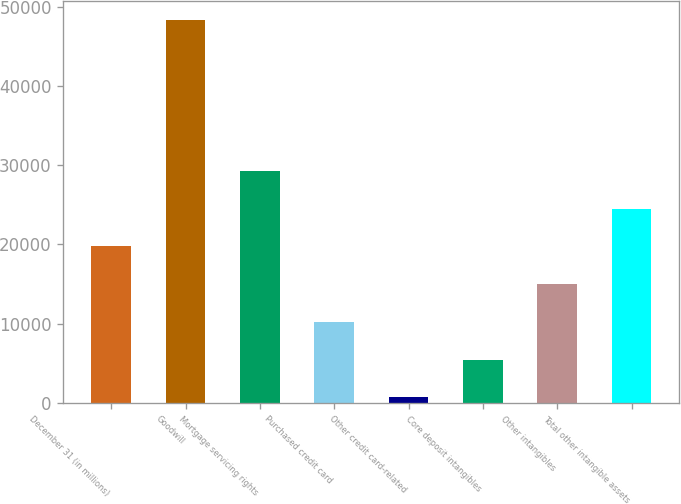Convert chart to OTSL. <chart><loc_0><loc_0><loc_500><loc_500><bar_chart><fcel>December 31 (in millions)<fcel>Goodwill<fcel>Mortgage servicing rights<fcel>Purchased credit card<fcel>Other credit card-related<fcel>Core deposit intangibles<fcel>Other intangibles<fcel>Total other intangible assets<nl><fcel>19757.4<fcel>48357<fcel>29290.6<fcel>10224.2<fcel>691<fcel>5457.6<fcel>14990.8<fcel>24524<nl></chart> 